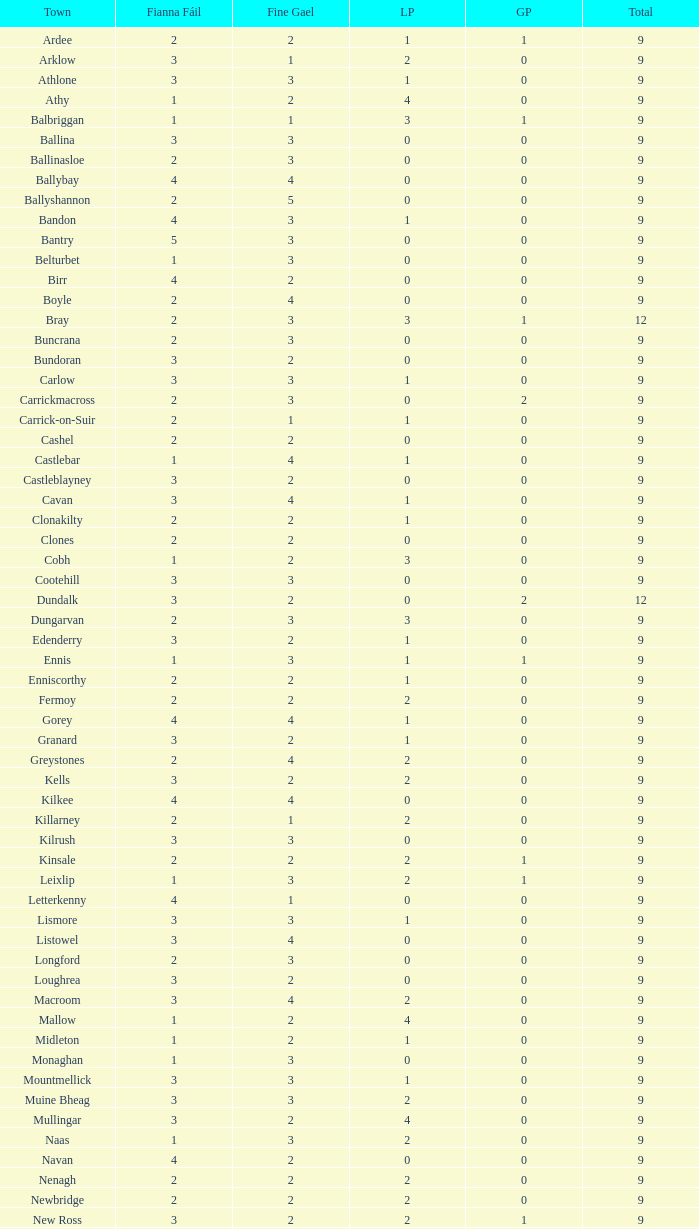How many are in the Green Party with a Fine Gael of less than 4 and a Fianna Fail of less than 2 in Athy? 0.0. 